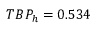<formula> <loc_0><loc_0><loc_500><loc_500>T B P _ { h } = 0 . 5 3 4</formula> 